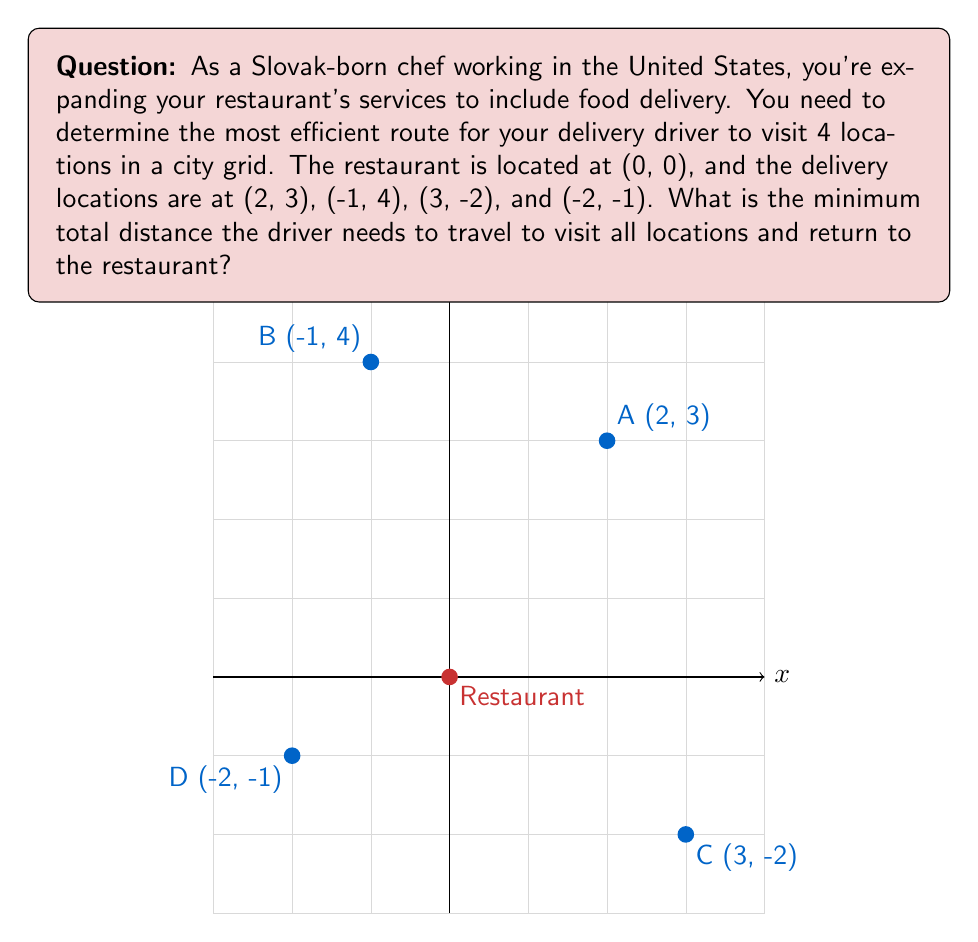Show me your answer to this math problem. To solve this problem, we need to use the concept of the Traveling Salesman Problem (TSP) and calculate the Manhattan distance between points.

Step 1: Calculate the Manhattan distances between all pairs of points.
Manhattan distance = |x1 - x2| + |y1 - y2|

Restaurant (0,0) to A(2,3): |0-2| + |0-3| = 2 + 3 = 5
Restaurant (0,0) to B(-1,4): |0-(-1)| + |0-4| = 1 + 4 = 5
Restaurant (0,0) to C(3,-2): |0-3| + |0-(-2)| = 3 + 2 = 5
Restaurant (0,0) to D(-2,-1): |0-(-2)| + |0-(-1)| = 2 + 1 = 3

A(2,3) to B(-1,4): |2-(-1)| + |3-4| = 3 + 1 = 4
A(2,3) to C(3,-2): |2-3| + |3-(-2)| = 1 + 5 = 6
A(2,3) to D(-2,-1): |2-(-2)| + |3-(-1)| = 4 + 4 = 8

B(-1,4) to C(3,-2): |(-1)-3| + |4-(-2)| = 4 + 6 = 10
B(-1,4) to D(-2,-1): |(-1)-(-2)| + |4-(-1)| = 1 + 5 = 6

C(3,-2) to D(-2,-1): |3-(-2)| + |(-2)-(-1)| = 5 + 1 = 6

Step 2: Find the shortest route.
There are 24 possible routes (4! = 24). We need to check all of them to find the shortest. Let's represent the restaurant as R.

The shortest route is: R → D → A → B → C → R
Distance: 3 + 8 + 4 + 10 + 5 = 30

Step 3: Verify that this is indeed the shortest route by checking a few alternatives:
R → A → B → C → D → R: 5 + 4 + 10 + 6 + 3 = 28
R → B → A → C → D → R: 5 + 4 + 6 + 6 + 3 = 24
R → C → A → B → D → R: 5 + 6 + 4 + 6 + 3 = 24

The route R → B → A → C → D → R and R → C → A → B → D → R both give the minimum distance of 24.
Answer: 24 units 